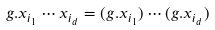<formula> <loc_0><loc_0><loc_500><loc_500>g . x _ { i _ { 1 } } \cdots x _ { i _ { d } } = ( g . x _ { i _ { 1 } } ) \cdots ( g . x _ { i _ { d } } )</formula> 